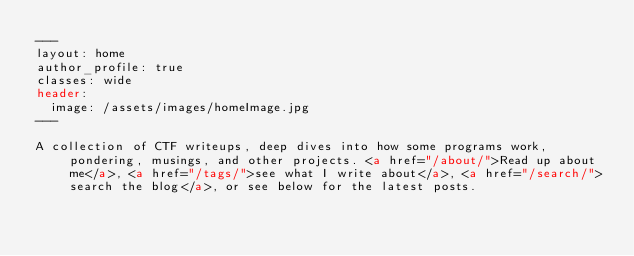Convert code to text. <code><loc_0><loc_0><loc_500><loc_500><_HTML_>---
layout: home
author_profile: true
classes: wide
header:
  image: /assets/images/homeImage.jpg
---

A collection of CTF writeups, deep dives into how some programs work, pondering, musings, and other projects. <a href="/about/">Read up about me</a>, <a href="/tags/">see what I write about</a>, <a href="/search/">search the blog</a>, or see below for the latest posts.
</code> 